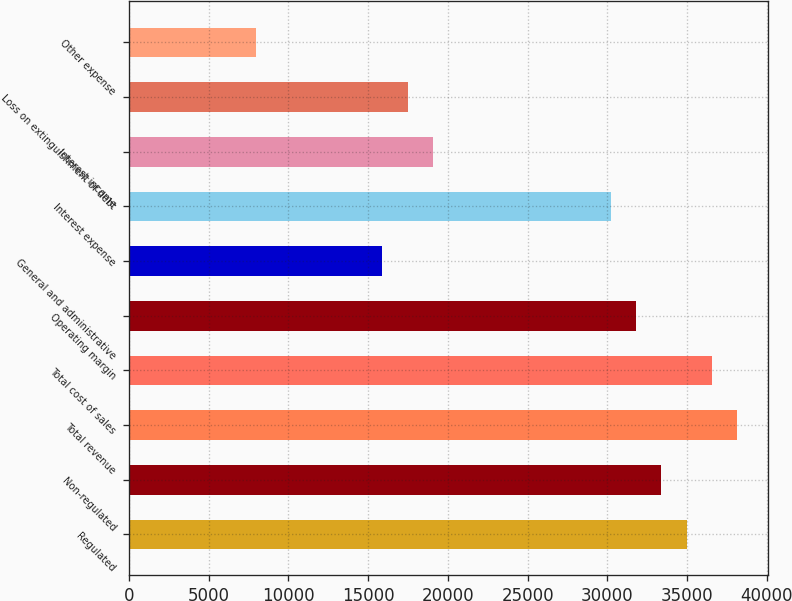Convert chart to OTSL. <chart><loc_0><loc_0><loc_500><loc_500><bar_chart><fcel>Regulated<fcel>Non-regulated<fcel>Total revenue<fcel>Total cost of sales<fcel>Operating margin<fcel>General and administrative<fcel>Interest expense<fcel>Interest income<fcel>Loss on extinguishment of debt<fcel>Other expense<nl><fcel>34960<fcel>33370.9<fcel>38138.2<fcel>36549.1<fcel>31781.8<fcel>15891<fcel>30192.8<fcel>19069.2<fcel>17480.1<fcel>7945.57<nl></chart> 